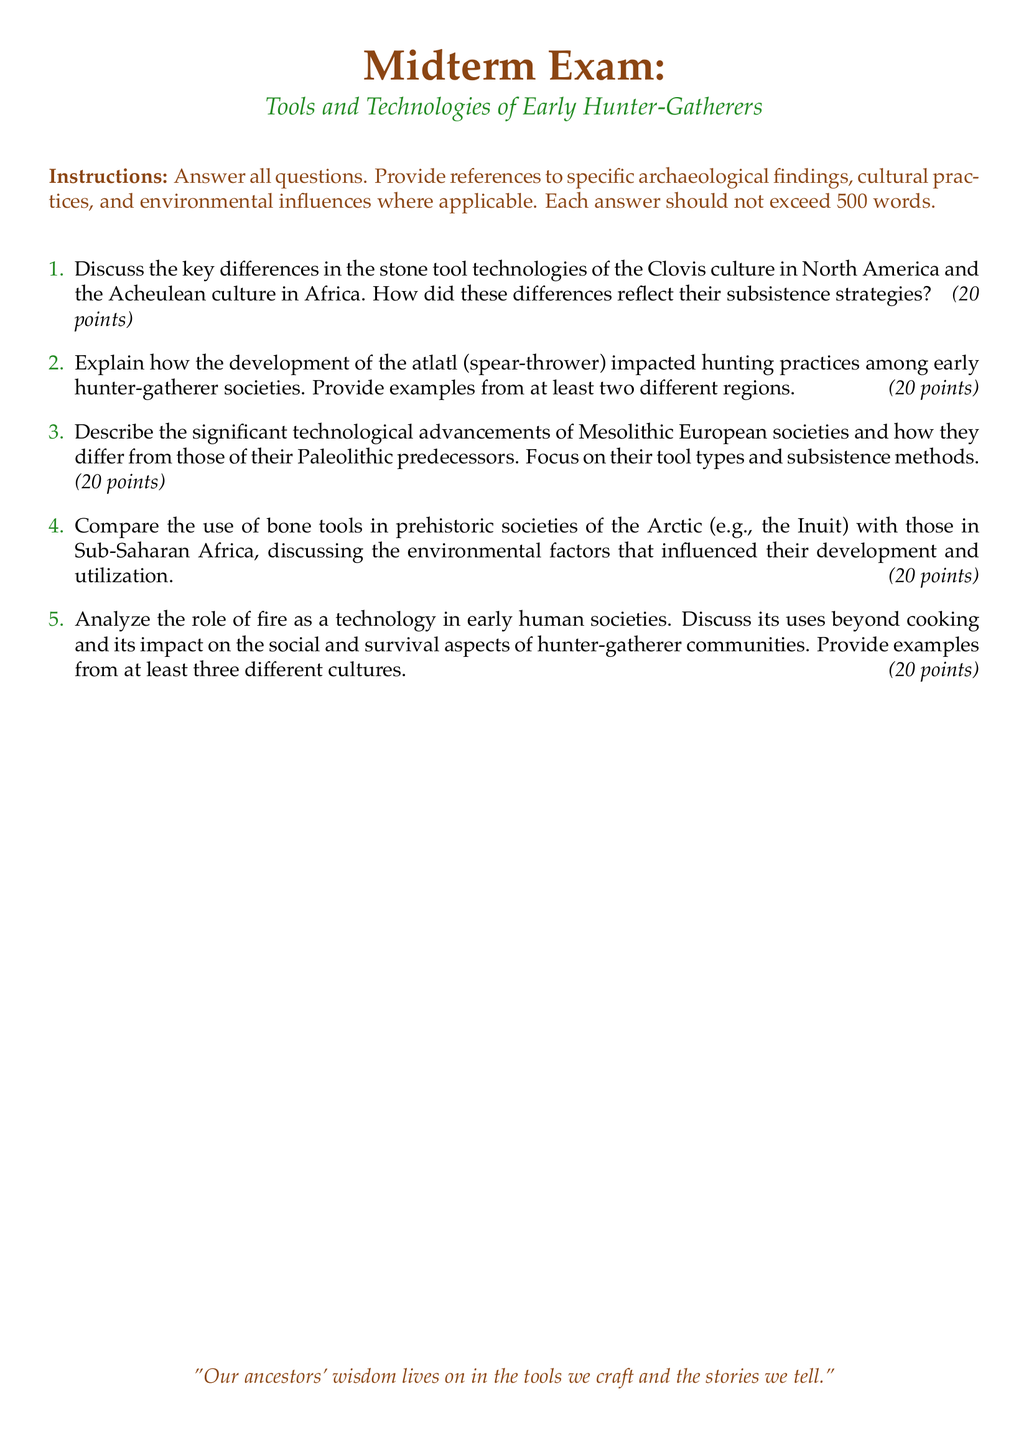What is the total points for each question? Each question in the exam is worth 20 points, as indicated in the document.
Answer: 20 points How many questions are there in the midterm exam? The document lists a total of five questions.
Answer: 5 Which cultures are compared in the first question? The first question compares the Clovis culture in North America and the Acheulean culture in Africa.
Answer: Clovis and Acheulean What artifact is mentioned as impacting hunting practices? The atlatl, or spear-thrower, is mentioned as impacting hunting practices in early societies.
Answer: Atlatl What period of European societies is focused on in the third question? The third question focuses on technological advancements of Mesolithic European societies.
Answer: Mesolithic What is the quote at the bottom of the document? The quote reflects the connection between ancestral wisdom, tools, and storytelling.
Answer: "Our ancestors' wisdom lives on in the tools we craft and the stories we tell." How does the document format the sections? The document uses a colored font for the section titles and has specific formatting for margins.
Answer: Colored font and specific margin format Which two regions are explicitly mentioned in the second question regarding the atlatl? The second question asks for examples from at least two different regions regarding the atlatl.
Answer: Two different regions What environmental factors are analyzed in question four? Question four discusses environmental factors influencing bone tool development in the Arctic and Sub-Saharan Africa.
Answer: Environmental factors 